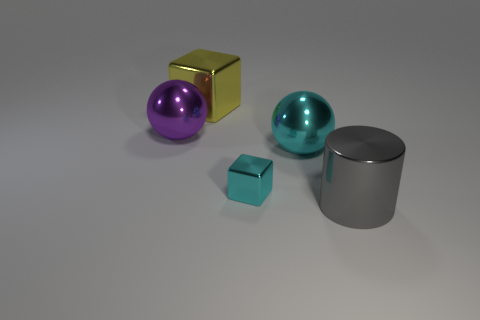Add 4 big cyan metallic things. How many objects exist? 9 Subtract all spheres. How many objects are left? 3 Add 1 big gray things. How many big gray things are left? 2 Add 3 big yellow objects. How many big yellow objects exist? 4 Subtract 0 gray balls. How many objects are left? 5 Subtract all tiny blocks. Subtract all yellow metal blocks. How many objects are left? 3 